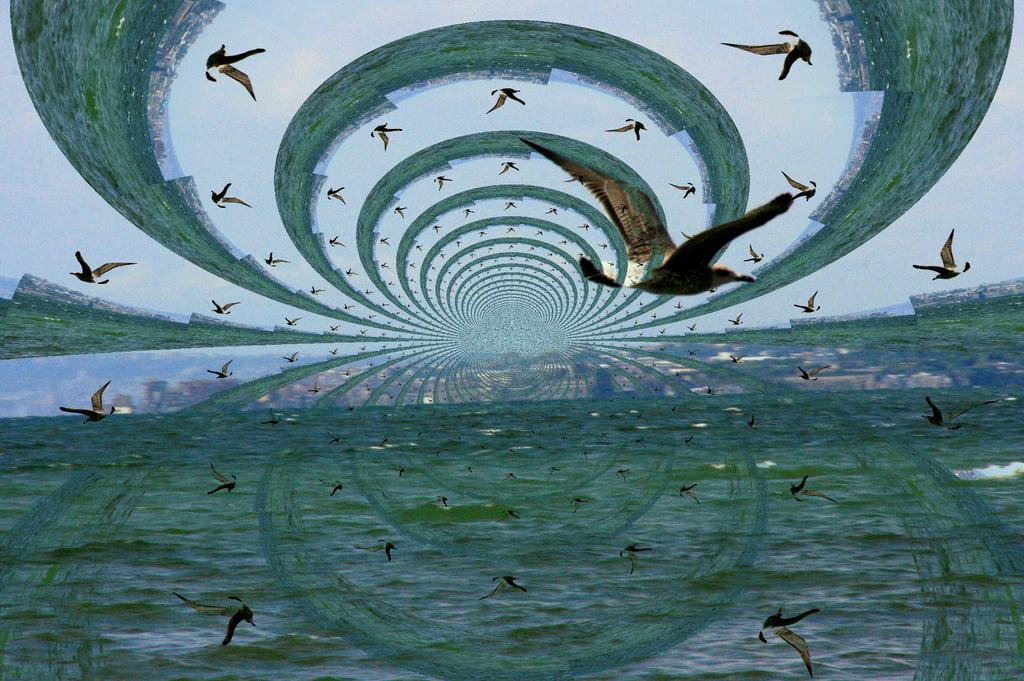What is one of the natural elements present in the image? There is water in the image. What type of animals can be seen in the image? There are flocks of birds in the image. What type of vegetation is visible in the image? Grass is visible in the image. What type of structures can be seen in the image? Houses are visible in the image. What part of the natural environment is visible in the image? The sky is visible in the image. What type of net is being used to catch the van in the image? There is no net or van present in the image. 